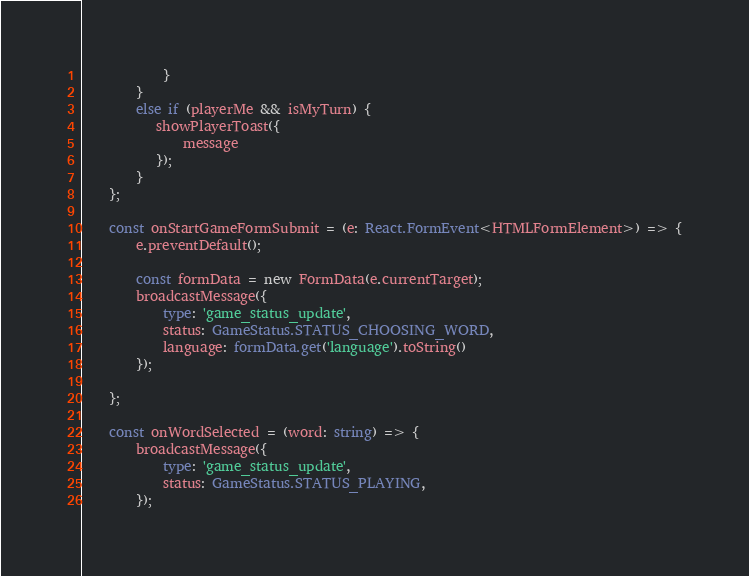<code> <loc_0><loc_0><loc_500><loc_500><_TypeScript_>            }
        }
        else if (playerMe && isMyTurn) {
           showPlayerToast({
               message
           });
        }
    };

    const onStartGameFormSubmit = (e: React.FormEvent<HTMLFormElement>) => {
        e.preventDefault();

        const formData = new FormData(e.currentTarget);
        broadcastMessage({
            type: 'game_status_update',
            status: GameStatus.STATUS_CHOOSING_WORD,
            language: formData.get('language').toString()
        });

    };

    const onWordSelected = (word: string) => {
        broadcastMessage({
            type: 'game_status_update',
            status: GameStatus.STATUS_PLAYING,
        });</code> 